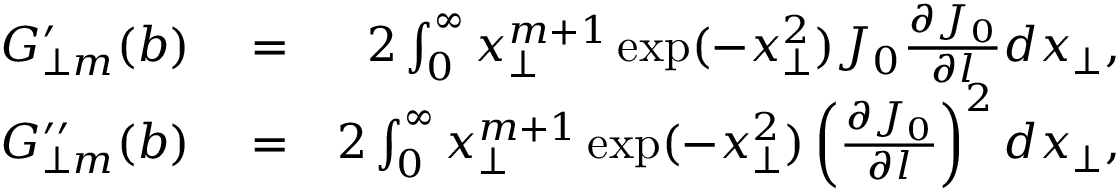Convert formula to latex. <formula><loc_0><loc_0><loc_500><loc_500>\begin{array} { r l r } { G _ { \perp m } ^ { \prime } ( b ) } & = } & { 2 \int _ { 0 } ^ { \infty } x _ { \perp } ^ { m + 1 } \exp ( - x _ { \perp } ^ { 2 } ) J _ { 0 } \frac { \partial J _ { 0 } } { \partial l } d x _ { \perp } , } \\ { G _ { \perp m } ^ { \prime \prime } ( b ) } & = } & { 2 \int _ { 0 } ^ { \infty } x _ { \perp } ^ { m + 1 } \exp ( - x _ { \perp } ^ { 2 } ) \left ( \frac { \partial J _ { 0 } } { \partial l } \right ) ^ { 2 } d x _ { \perp } , } \end{array}</formula> 